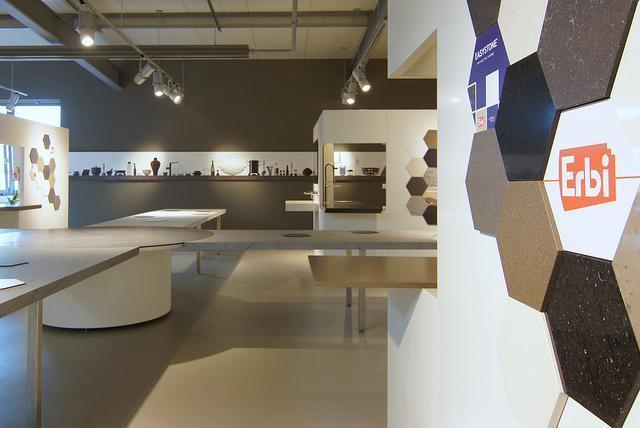This showroom specializes in which home renovation product?
Choose the right answer and clarify with the format: 'Answer: answer
Rationale: rationale.'
Options: Kitchen counters, cabinets, electronics, lighting. Answer: kitchen counters.
Rationale: The showroom has a bunch of counter spaces. 